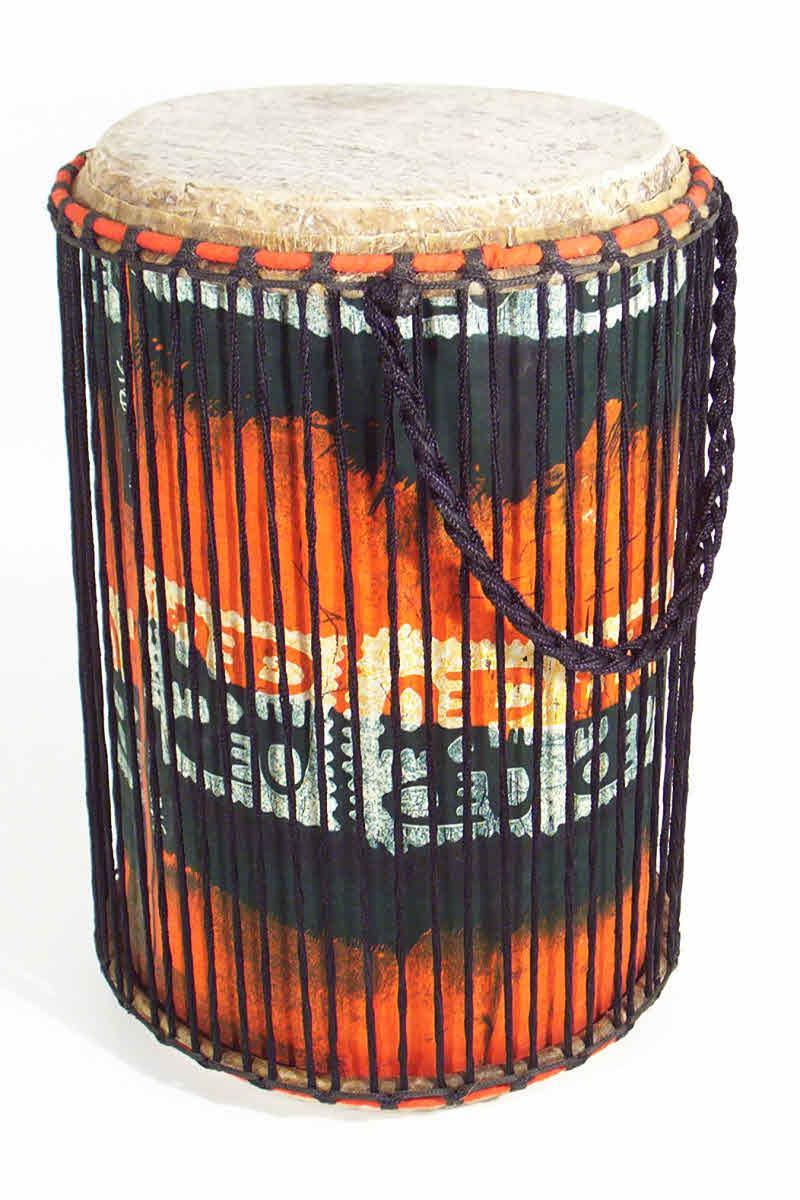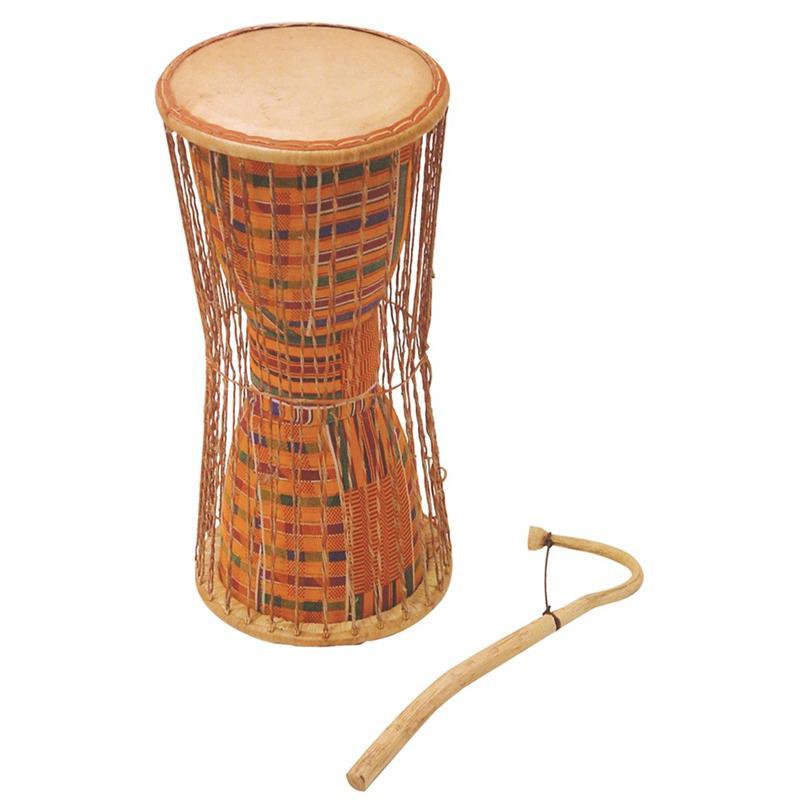The first image is the image on the left, the second image is the image on the right. For the images displayed, is the sentence "One image shows three close-together upright drums, with two standing in front and a bigger one behind them." factually correct? Answer yes or no. No. The first image is the image on the left, the second image is the image on the right. Analyze the images presented: Is the assertion "There are at least four drums." valid? Answer yes or no. No. 